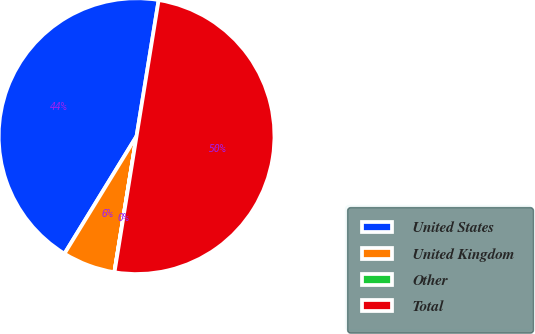<chart> <loc_0><loc_0><loc_500><loc_500><pie_chart><fcel>United States<fcel>United Kingdom<fcel>Other<fcel>Total<nl><fcel>43.8%<fcel>6.18%<fcel>0.02%<fcel>50.0%<nl></chart> 